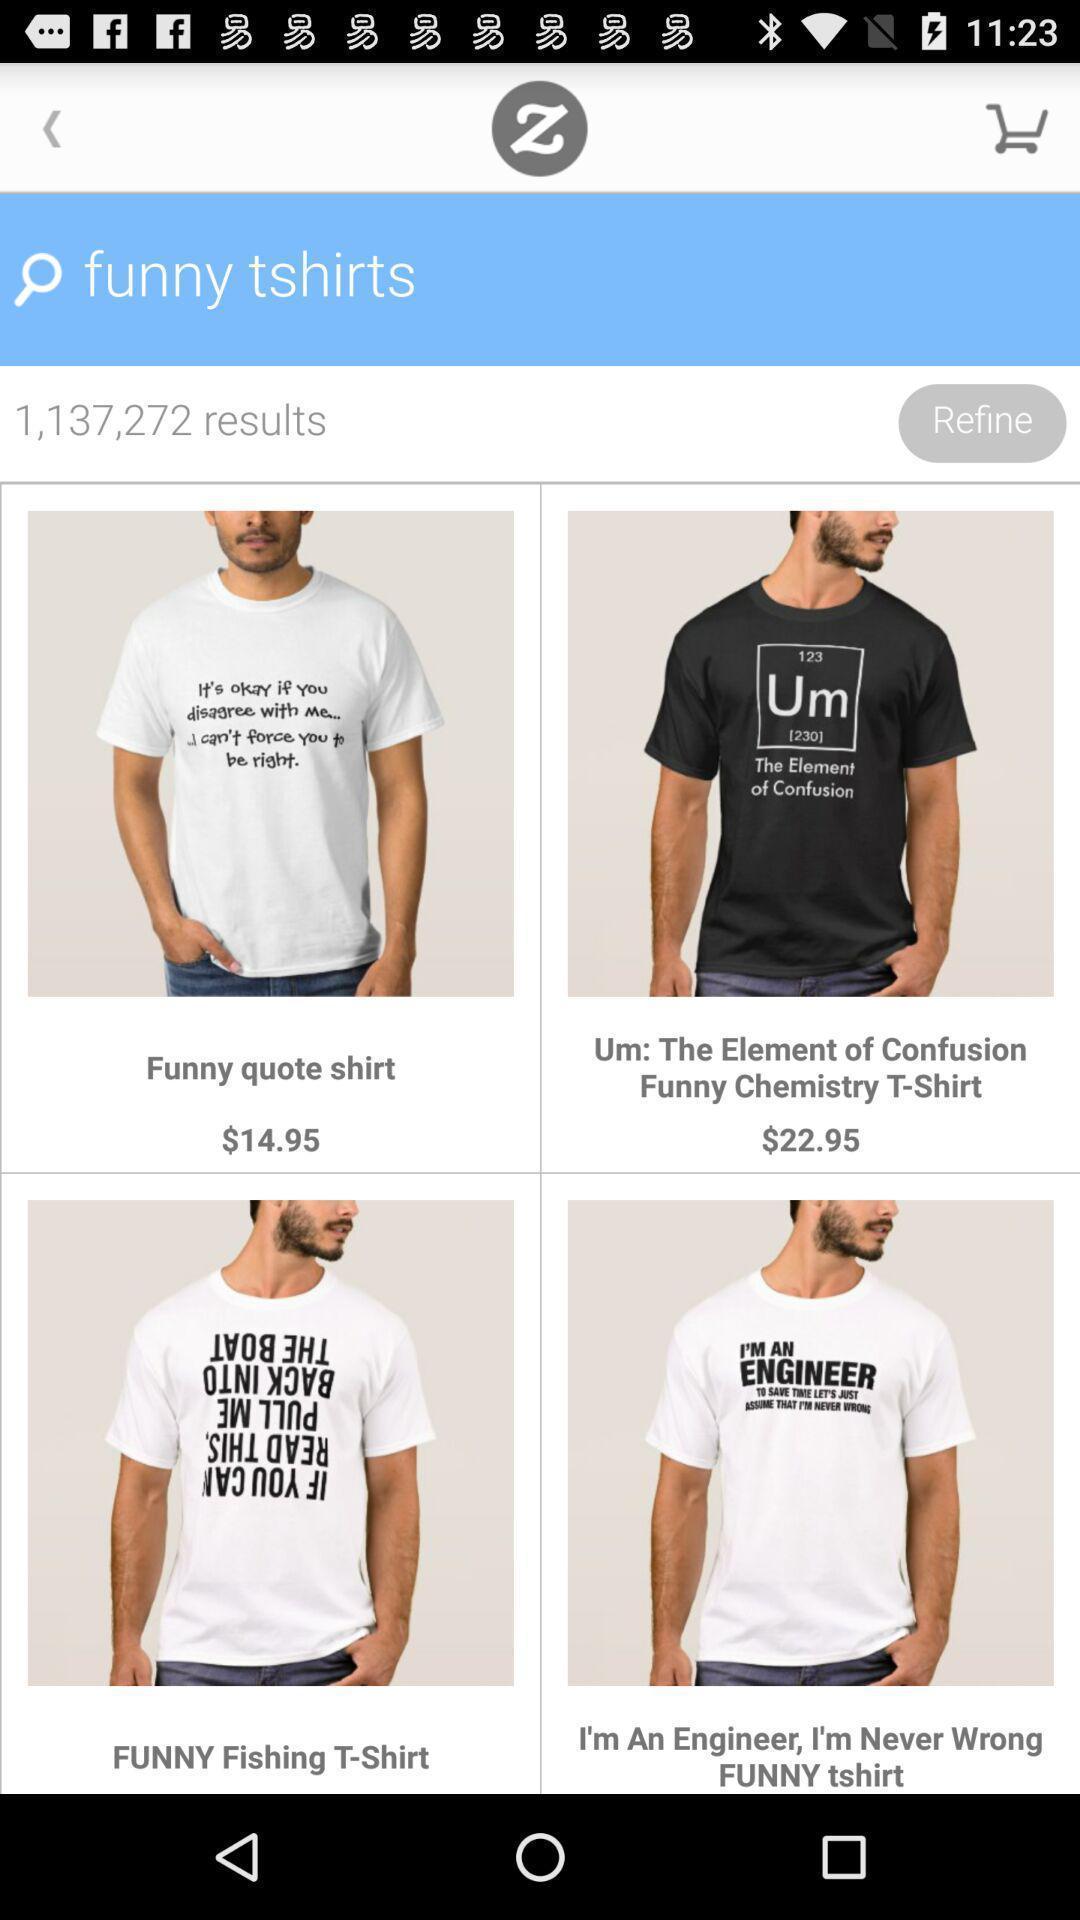Describe the key features of this screenshot. Screen shows funny t shirts from an online store. 